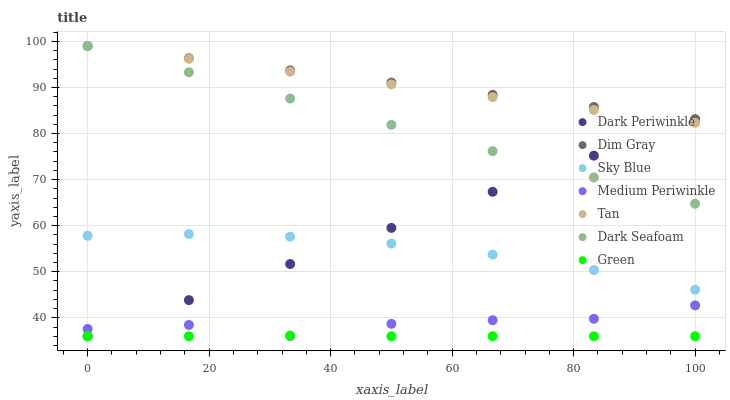Does Green have the minimum area under the curve?
Answer yes or no. Yes. Does Dim Gray have the maximum area under the curve?
Answer yes or no. Yes. Does Medium Periwinkle have the minimum area under the curve?
Answer yes or no. No. Does Medium Periwinkle have the maximum area under the curve?
Answer yes or no. No. Is Dark Periwinkle the smoothest?
Answer yes or no. Yes. Is Medium Periwinkle the roughest?
Answer yes or no. Yes. Is Dark Seafoam the smoothest?
Answer yes or no. No. Is Dark Seafoam the roughest?
Answer yes or no. No. Does Green have the lowest value?
Answer yes or no. Yes. Does Medium Periwinkle have the lowest value?
Answer yes or no. No. Does Tan have the highest value?
Answer yes or no. Yes. Does Medium Periwinkle have the highest value?
Answer yes or no. No. Is Sky Blue less than Tan?
Answer yes or no. Yes. Is Tan greater than Sky Blue?
Answer yes or no. Yes. Does Tan intersect Dim Gray?
Answer yes or no. Yes. Is Tan less than Dim Gray?
Answer yes or no. No. Is Tan greater than Dim Gray?
Answer yes or no. No. Does Sky Blue intersect Tan?
Answer yes or no. No. 